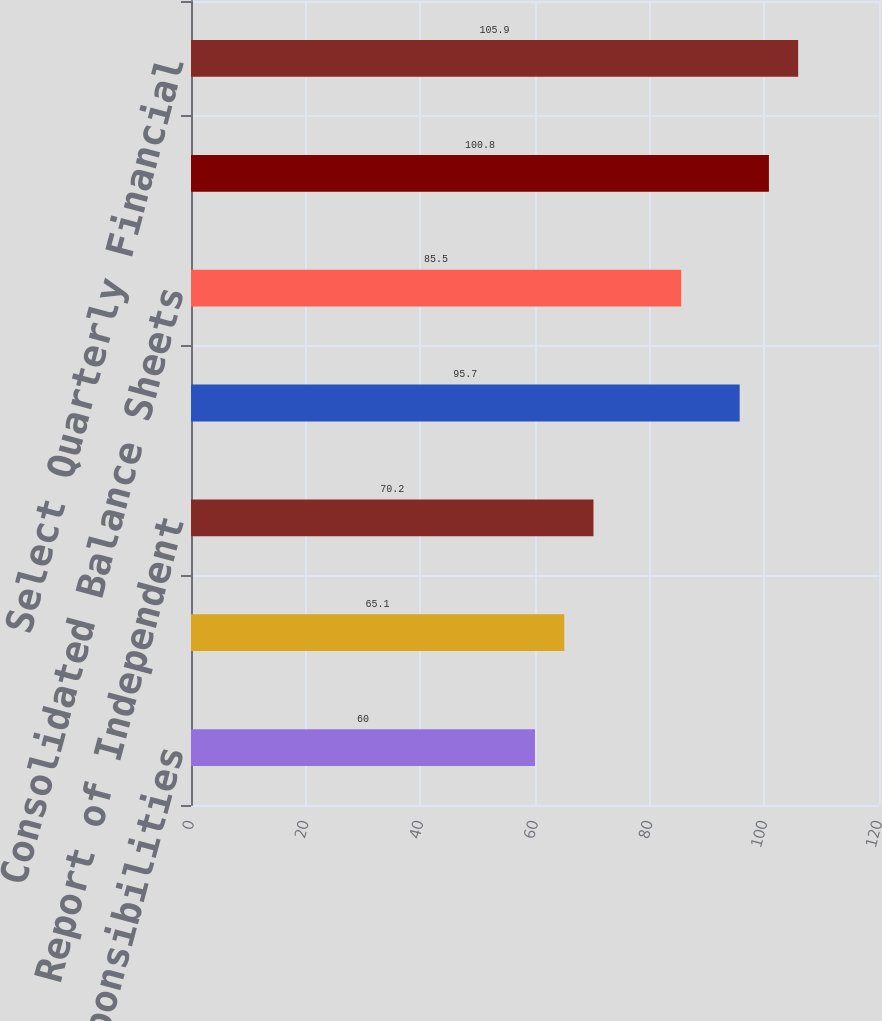<chart> <loc_0><loc_0><loc_500><loc_500><bar_chart><fcel>Management's Responsibilities<fcel>Management's Report on<fcel>Report of Independent<fcel>Consolidated Statements of<fcel>Consolidated Balance Sheets<fcel>Notes to Consolidated<fcel>Select Quarterly Financial<nl><fcel>60<fcel>65.1<fcel>70.2<fcel>95.7<fcel>85.5<fcel>100.8<fcel>105.9<nl></chart> 